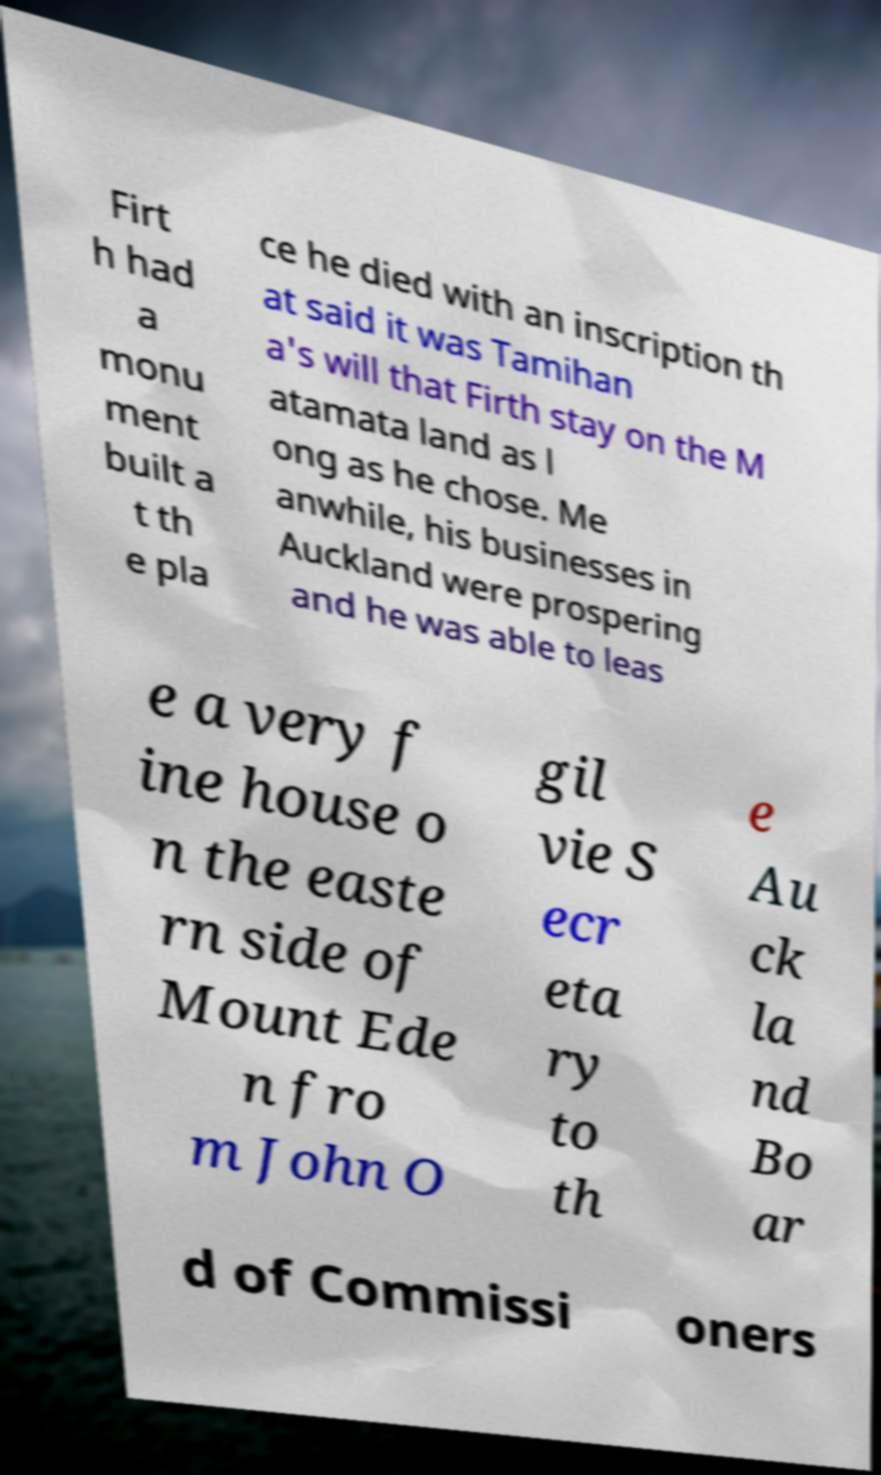Can you accurately transcribe the text from the provided image for me? Firt h had a monu ment built a t th e pla ce he died with an inscription th at said it was Tamihan a's will that Firth stay on the M atamata land as l ong as he chose. Me anwhile, his businesses in Auckland were prospering and he was able to leas e a very f ine house o n the easte rn side of Mount Ede n fro m John O gil vie S ecr eta ry to th e Au ck la nd Bo ar d of Commissi oners 